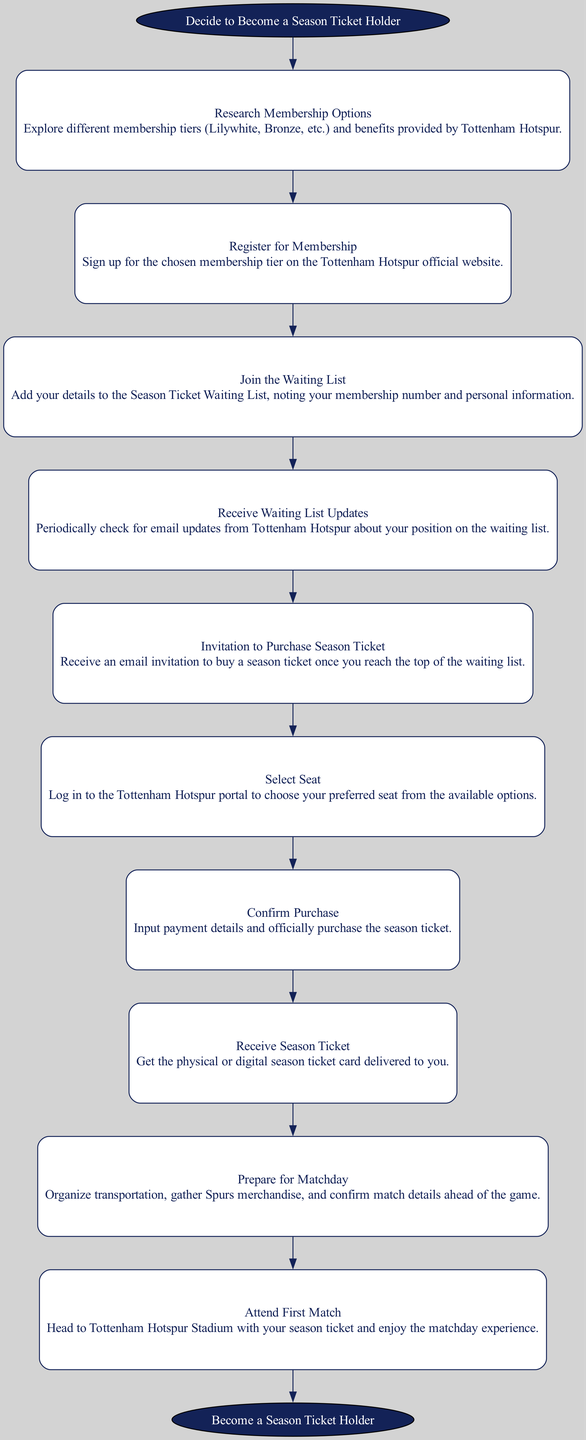What is the first step in the journey of becoming a season ticket holder? The first step, as indicated in the diagram, is "Decide to Become a Season Ticket Holder," which initiates the entire process.
Answer: Decide to Become a Season Ticket Holder How many steps are there in the process leading to becoming a season ticket holder? The diagram lists 10 distinct steps, including the initial step and the final outcome, showing the complete flow towards obtaining a season ticket.
Answer: 10 Which step comes after "Join the Waiting List"? According to the diagram, the step that follows "Join the Waiting List" is "Receive Waiting List Updates," indicating the sequence of actions taken.
Answer: Receive Waiting List Updates What does "Select Seat" involve? The step "Select Seat" details that as a member, you need to log into the Tottenham Hotspur portal to choose a preferred seat, confirming your wish to attend games.
Answer: Log in to the Tottenham Hotspur portal to choose your preferred seat What is the final step in the journey to becoming a season ticket holder? The last action depicted in the flow chart is "Attend First Match," which signifies the culmination of all previous steps in the process of becoming a season ticket holder.
Answer: Attend First Match What happens before “Confirm Purchase”? The step that precedes "Confirm Purchase" is "Select Seat." This indicates that choosing a seat is necessary before you can proceed with confirming the ticket purchase.
Answer: Select Seat Why is it important to “Receive Waiting List Updates”? "Receive Waiting List Updates" is crucial because it allows applicants to monitor their status and stay informed about their progress on the waiting list, which can influence their next steps in the process.
Answer: To monitor status on the waiting list 